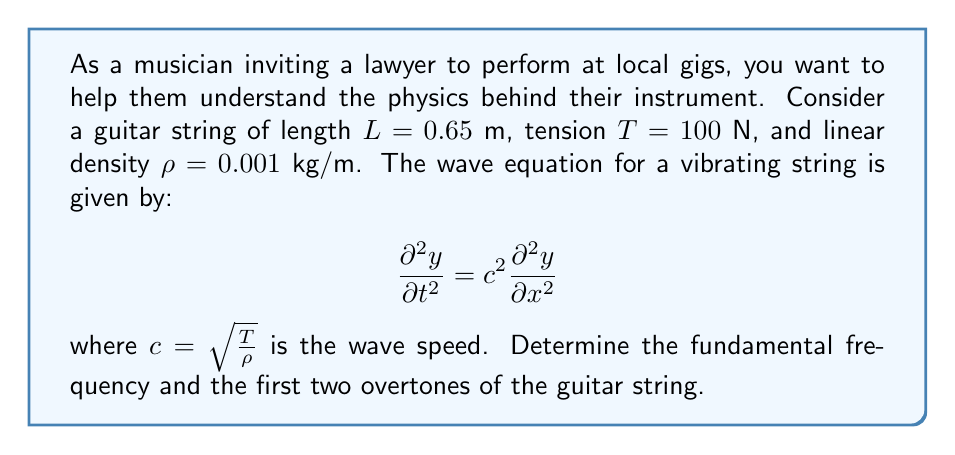Give your solution to this math problem. To solve this problem, we'll follow these steps:

1) First, calculate the wave speed $c$:
   $$c = \sqrt{\frac{T}{\rho}} = \sqrt{\frac{100}{0.001}} = 316.23 \text{ m/s}$$

2) The general solution for the wave equation with fixed ends (as in a guitar string) is:
   $$y(x,t) = \sum_{n=1}^{\infty} A_n \sin(\frac{n\pi x}{L}) \cos(\frac{n\pi c}{L}t)$$

3) The frequencies of vibration are given by:
   $$f_n = \frac{nc}{2L}$$
   where $n = 1, 2, 3, ...$ corresponds to the fundamental frequency and overtones.

4) Calculate the fundamental frequency ($n = 1$):
   $$f_1 = \frac{1 \cdot 316.23}{2 \cdot 0.65} = 243.25 \text{ Hz}$$

5) Calculate the first overtone ($n = 2$):
   $$f_2 = \frac{2 \cdot 316.23}{2 \cdot 0.65} = 486.51 \text{ Hz}$$

6) Calculate the second overtone ($n = 3$):
   $$f_3 = \frac{3 \cdot 316.23}{2 \cdot 0.65} = 729.76 \text{ Hz}$$
Answer: Fundamental frequency: 243.25 Hz; First overtone: 486.51 Hz; Second overtone: 729.76 Hz 